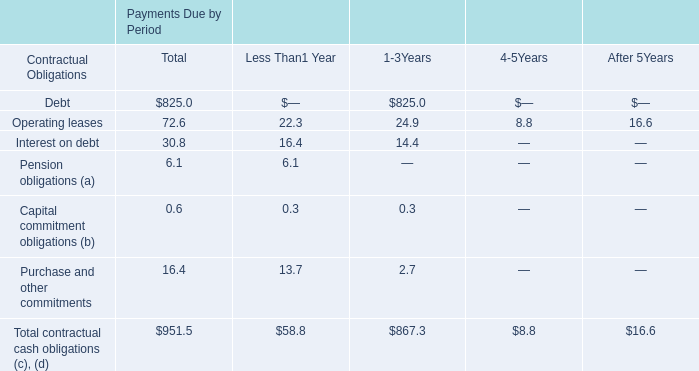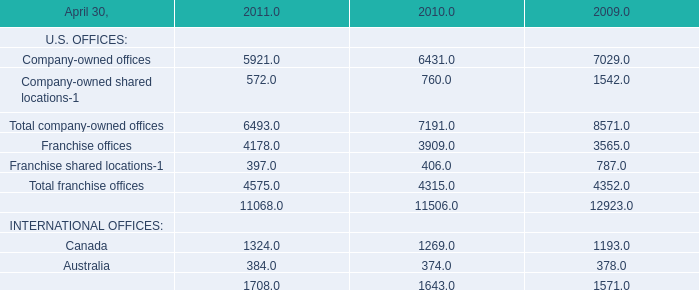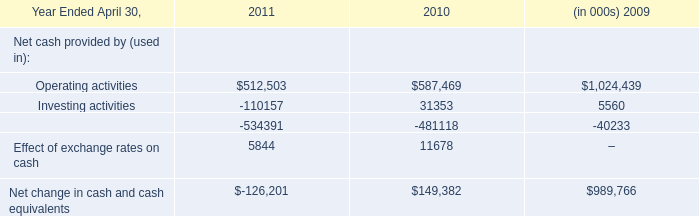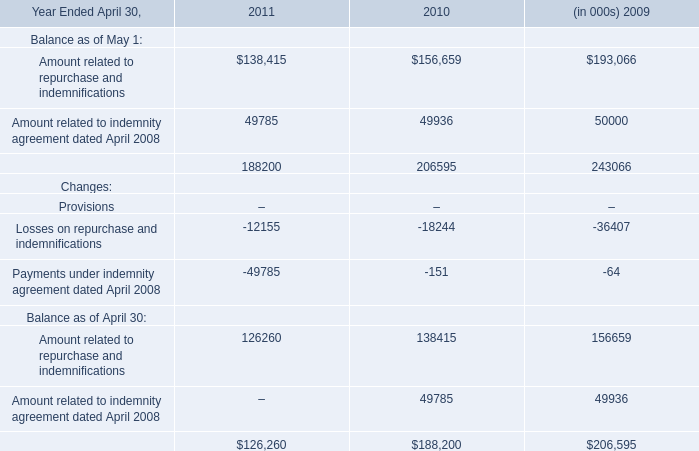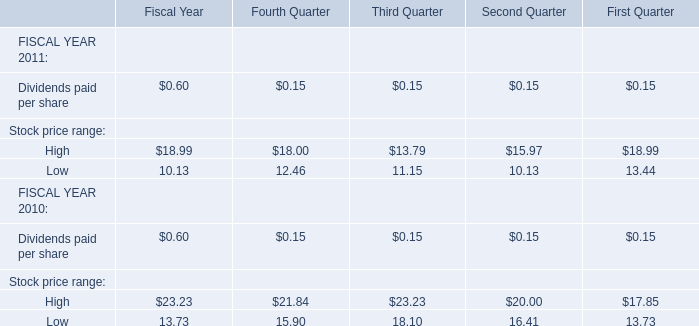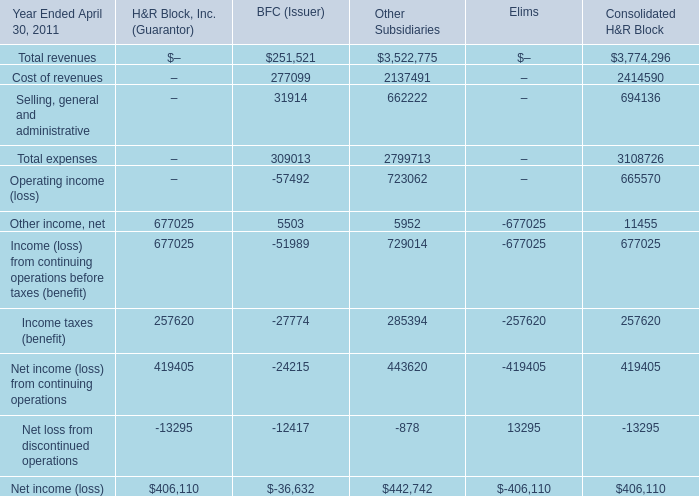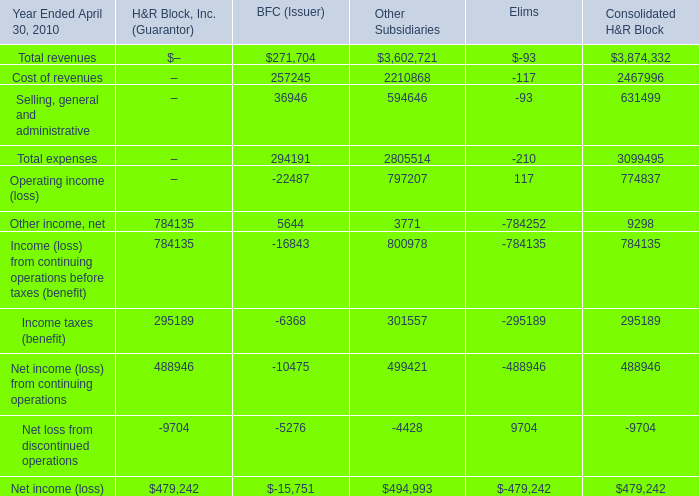what is the highest total amount of Other income, net? 
Answer: 677025. 